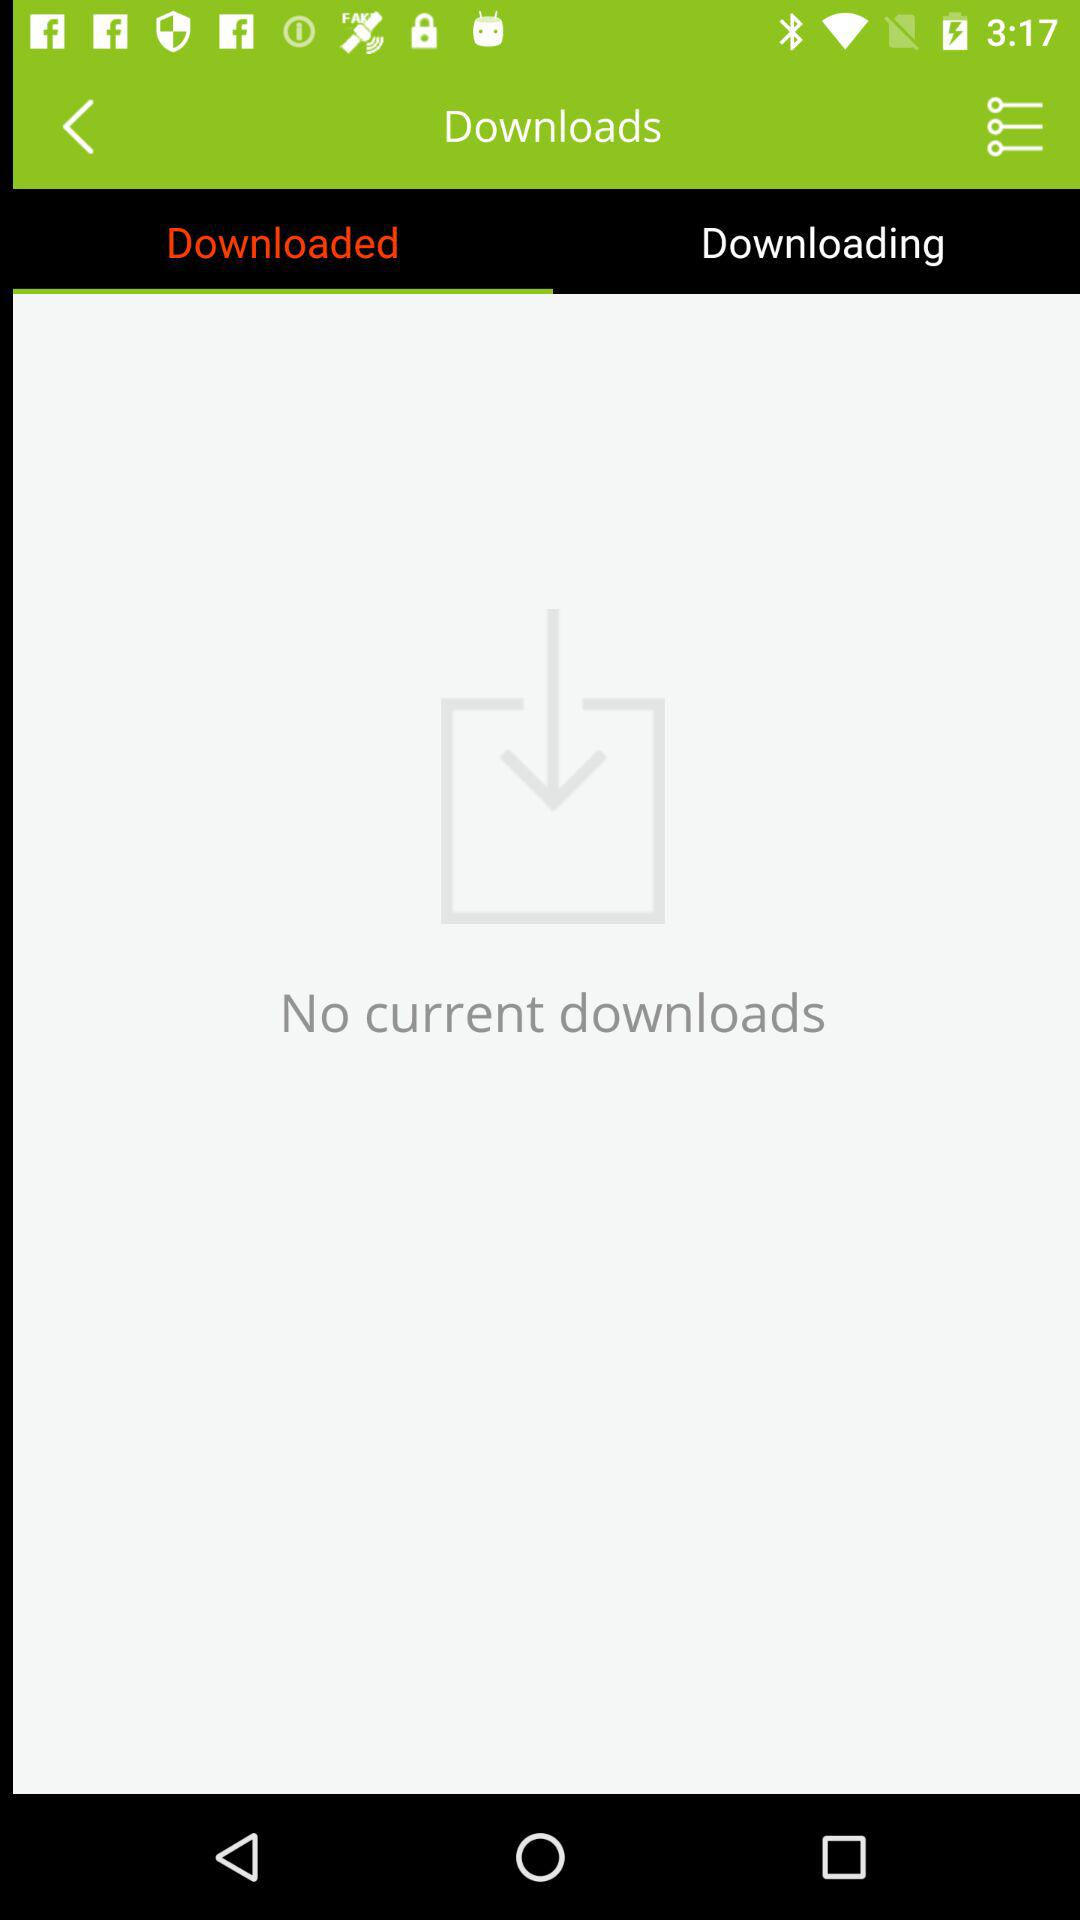Which tab is selected? The selected tab is "Downloaded". 